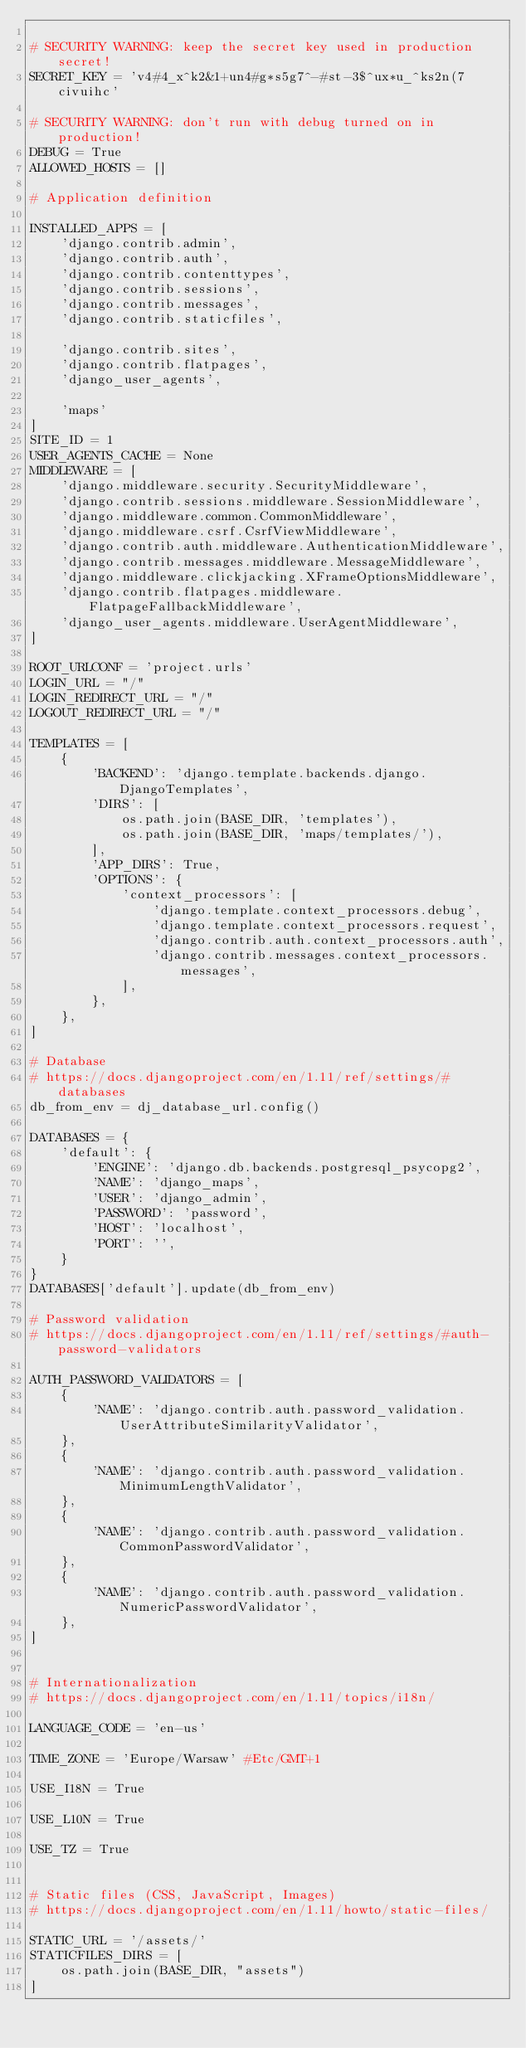Convert code to text. <code><loc_0><loc_0><loc_500><loc_500><_Python_>
# SECURITY WARNING: keep the secret key used in production secret!
SECRET_KEY = 'v4#4_x^k2&1+un4#g*s5g7^-#st-3$^ux*u_^ks2n(7civuihc'

# SECURITY WARNING: don't run with debug turned on in production!
DEBUG = True
ALLOWED_HOSTS = []

# Application definition

INSTALLED_APPS = [
    'django.contrib.admin',
    'django.contrib.auth',
    'django.contrib.contenttypes',
    'django.contrib.sessions',
    'django.contrib.messages',
    'django.contrib.staticfiles',
    
    'django.contrib.sites',
    'django.contrib.flatpages',
    'django_user_agents',

    'maps'
]
SITE_ID = 1
USER_AGENTS_CACHE = None
MIDDLEWARE = [
    'django.middleware.security.SecurityMiddleware',
    'django.contrib.sessions.middleware.SessionMiddleware',
    'django.middleware.common.CommonMiddleware',
    'django.middleware.csrf.CsrfViewMiddleware',
    'django.contrib.auth.middleware.AuthenticationMiddleware',
    'django.contrib.messages.middleware.MessageMiddleware',
    'django.middleware.clickjacking.XFrameOptionsMiddleware',
    'django.contrib.flatpages.middleware.FlatpageFallbackMiddleware',
    'django_user_agents.middleware.UserAgentMiddleware',
]

ROOT_URLCONF = 'project.urls'
LOGIN_URL = "/"
LOGIN_REDIRECT_URL = "/"
LOGOUT_REDIRECT_URL = "/"

TEMPLATES = [
    {
        'BACKEND': 'django.template.backends.django.DjangoTemplates',
        'DIRS': [
            os.path.join(BASE_DIR, 'templates'),
            os.path.join(BASE_DIR, 'maps/templates/'),
        ],
        'APP_DIRS': True,
        'OPTIONS': {
            'context_processors': [
                'django.template.context_processors.debug',
                'django.template.context_processors.request',
                'django.contrib.auth.context_processors.auth',
                'django.contrib.messages.context_processors.messages',
            ],
        },
    },
]

# Database
# https://docs.djangoproject.com/en/1.11/ref/settings/#databases
db_from_env = dj_database_url.config()

DATABASES = {
    'default': {
        'ENGINE': 'django.db.backends.postgresql_psycopg2',
        'NAME': 'django_maps',
        'USER': 'django_admin',
        'PASSWORD': 'password',
        'HOST': 'localhost',
        'PORT': '',
    }
}
DATABASES['default'].update(db_from_env)

# Password validation
# https://docs.djangoproject.com/en/1.11/ref/settings/#auth-password-validators

AUTH_PASSWORD_VALIDATORS = [
    {
        'NAME': 'django.contrib.auth.password_validation.UserAttributeSimilarityValidator',
    },
    {
        'NAME': 'django.contrib.auth.password_validation.MinimumLengthValidator',
    },
    {
        'NAME': 'django.contrib.auth.password_validation.CommonPasswordValidator',
    },
    {
        'NAME': 'django.contrib.auth.password_validation.NumericPasswordValidator',
    },
]


# Internationalization
# https://docs.djangoproject.com/en/1.11/topics/i18n/

LANGUAGE_CODE = 'en-us'

TIME_ZONE = 'Europe/Warsaw' #Etc/GMT+1

USE_I18N = True

USE_L10N = True

USE_TZ = True


# Static files (CSS, JavaScript, Images)
# https://docs.djangoproject.com/en/1.11/howto/static-files/

STATIC_URL = '/assets/'
STATICFILES_DIRS = [
    os.path.join(BASE_DIR, "assets")
]
</code> 